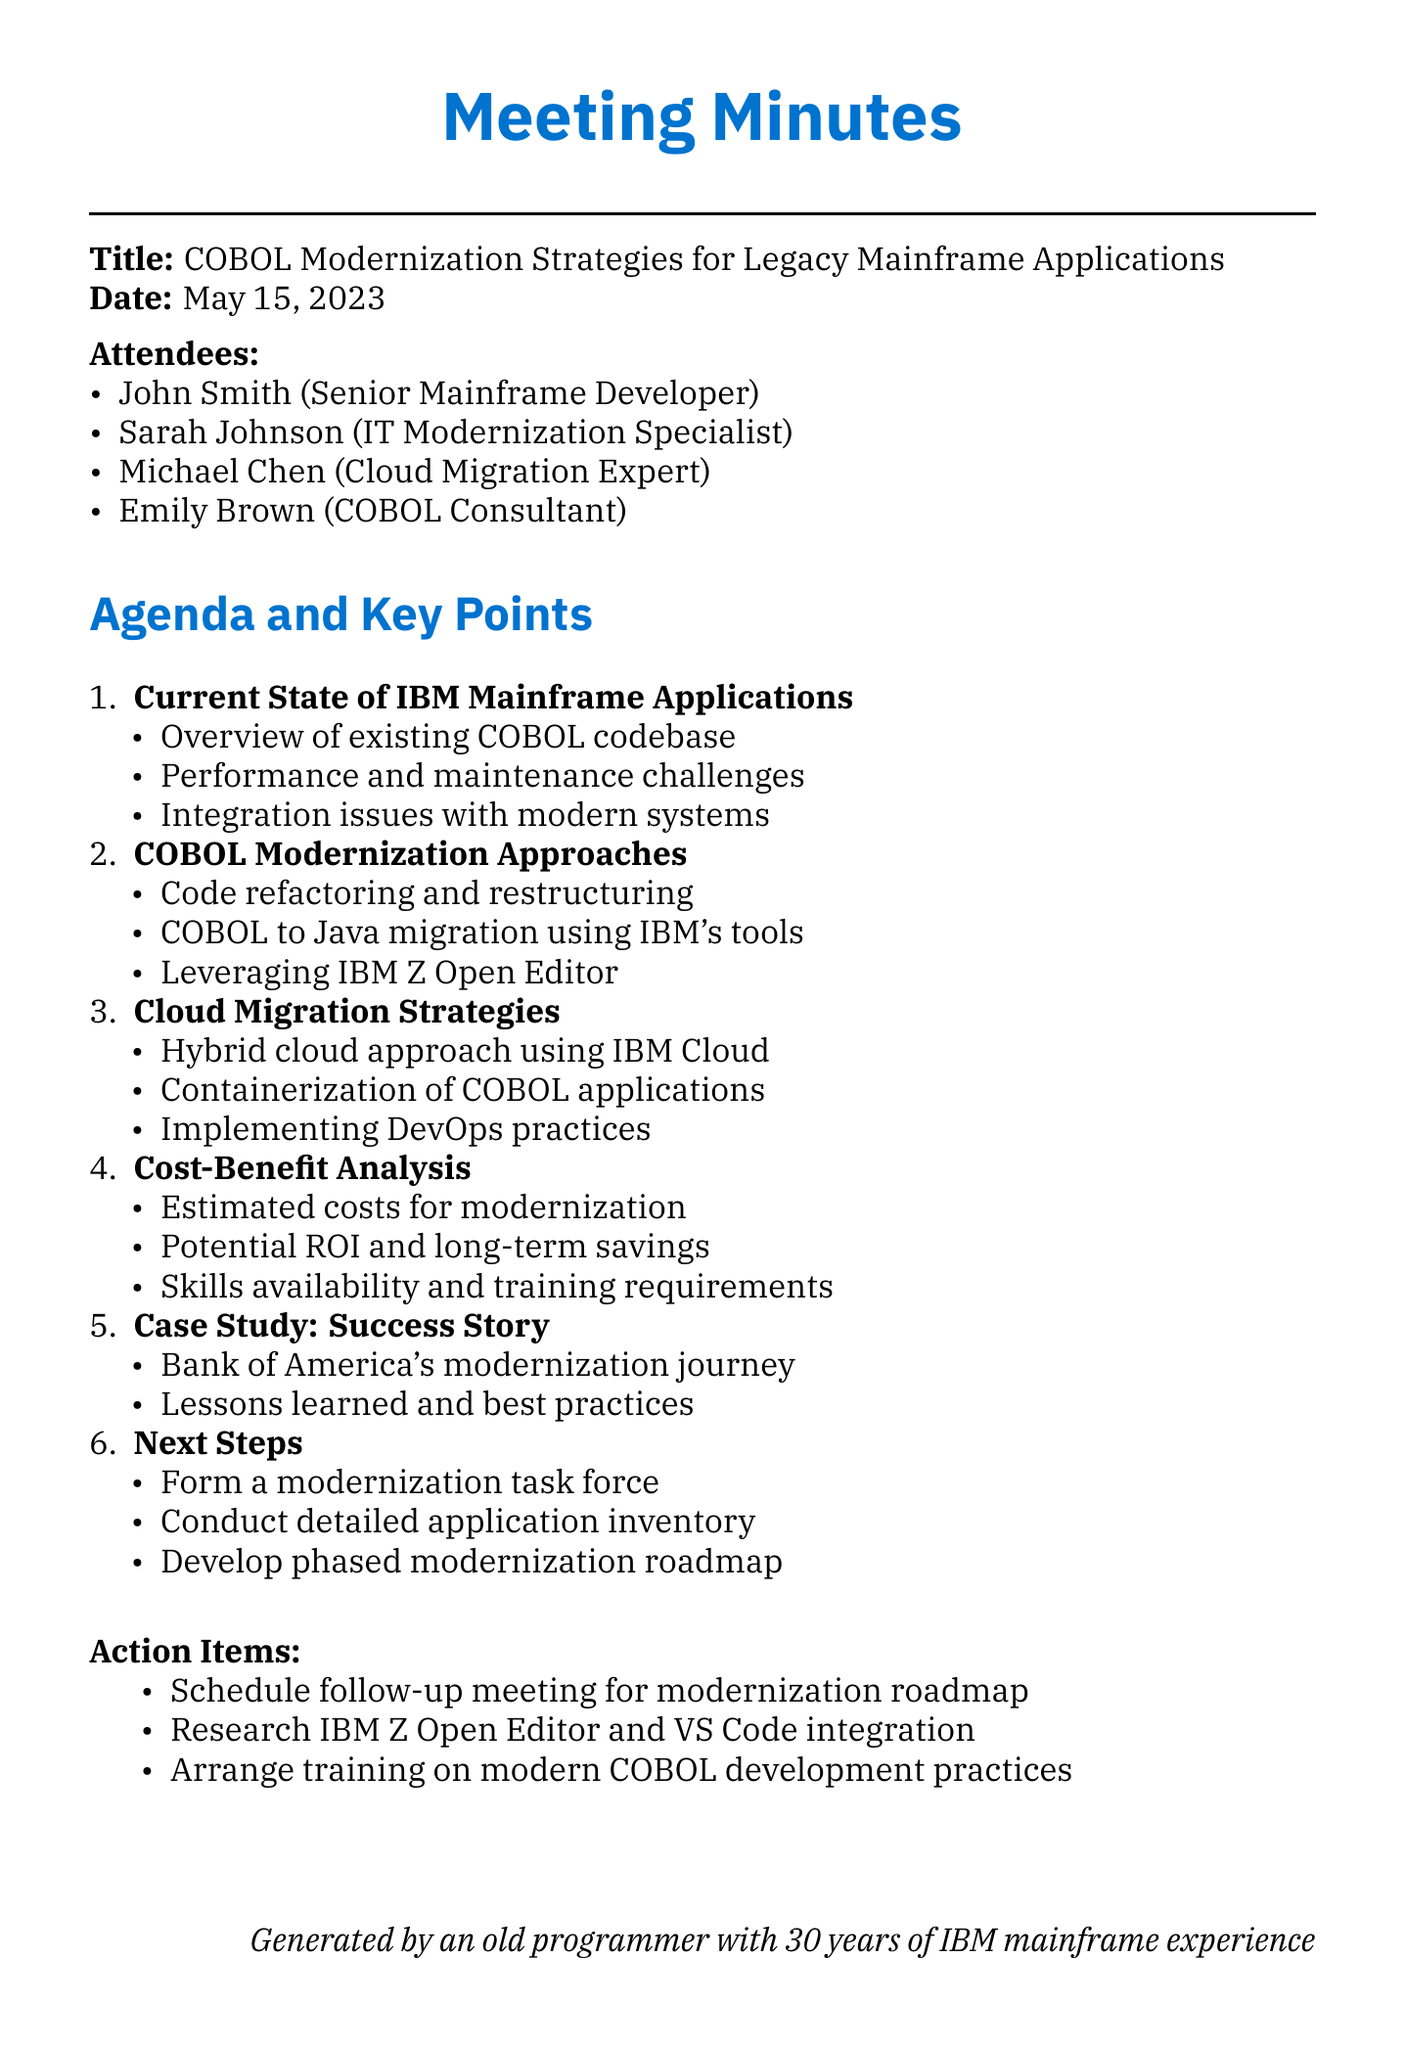what is the meeting title? The meeting title is provided in the document under the title section.
Answer: COBOL Modernization Strategies for Legacy Mainframe Applications who is the IT Modernization Specialist? The document lists attendees and their roles, including the IT Modernization Specialist.
Answer: Sarah Johnson what date was the meeting held? The date of the meeting is clearly stated in the document.
Answer: May 15, 2023 what is the first agenda item discussed? The agenda items are listed, and the first one can be found at the beginning of the list.
Answer: Current State of IBM Mainframe Applications name one cloud migration strategy mentioned in the meeting. The document includes key points under the cloud migration strategies section.
Answer: Hybrid cloud approach using IBM Cloud what case study was discussed as a success story? The document mentions a specific case study that exemplifies success in modernization.
Answer: Bank of America's mainframe modernization journey what action item involves researching a specific tool? The action items are listed, and one involves research on a specific tool.
Answer: Research IBM Z Open Editor and its integration with VS Code how many attendees were present at the meeting? The number of attendees can be counted from the list provided in the document.
Answer: Four 